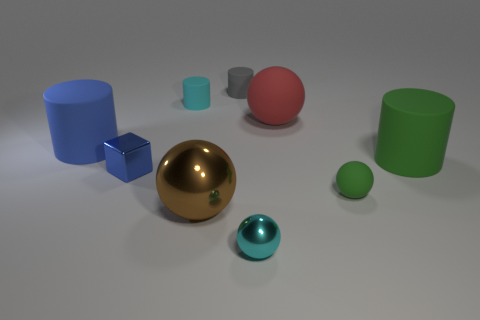Add 1 cyan cubes. How many objects exist? 10 Subtract all balls. How many objects are left? 5 Subtract 1 red spheres. How many objects are left? 8 Subtract all cyan cylinders. Subtract all cyan spheres. How many objects are left? 7 Add 4 blue cubes. How many blue cubes are left? 5 Add 7 matte blocks. How many matte blocks exist? 7 